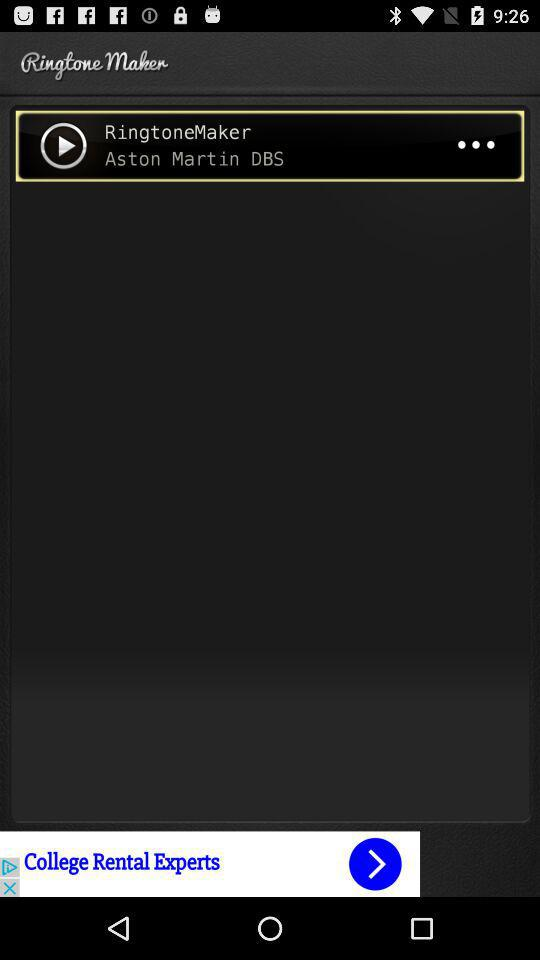What is the name of the ringtone? The name of the ringtone is "RingtoneMaker". 